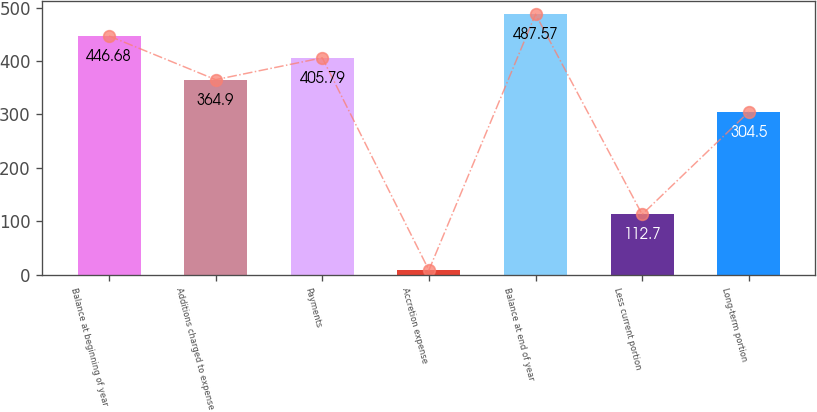<chart> <loc_0><loc_0><loc_500><loc_500><bar_chart><fcel>Balance at beginning of year<fcel>Additions charged to expense<fcel>Payments<fcel>Accretion expense<fcel>Balance at end of year<fcel>Less current portion<fcel>Long-term portion<nl><fcel>446.68<fcel>364.9<fcel>405.79<fcel>8.3<fcel>487.57<fcel>112.7<fcel>304.5<nl></chart> 